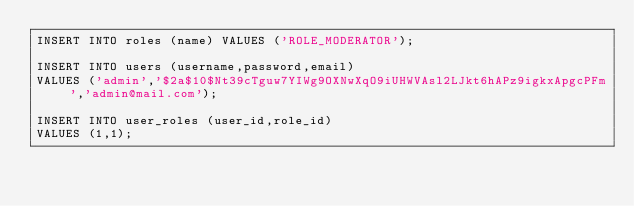Convert code to text. <code><loc_0><loc_0><loc_500><loc_500><_SQL_>INSERT INTO roles (name) VALUES ('ROLE_MODERATOR');

INSERT INTO users (username,password,email) 
VALUES ('admin','$2a$10$Nt39cTguw7YIWg9OXNwXqO9iUHWVAsl2LJkt6hAPz9igkxApgcPFm','admin@mail.com');

INSERT INTO user_roles (user_id,role_id) 
VALUES (1,1);

</code> 